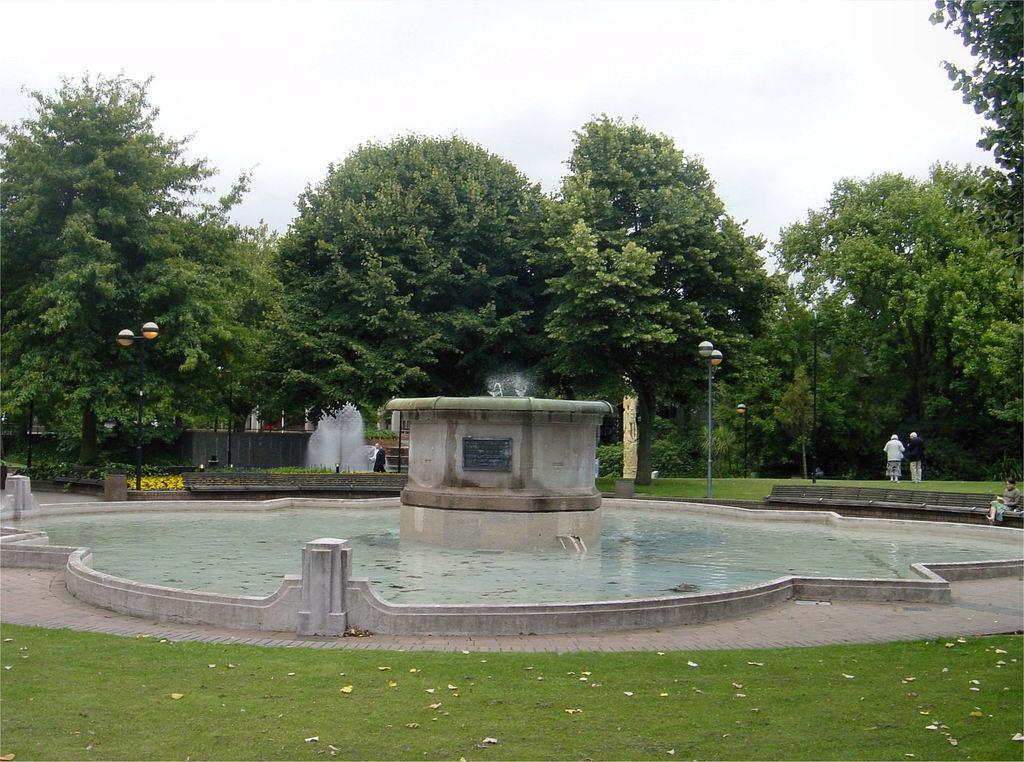In one or two sentences, can you explain what this image depicts? In the background we can see sky, trees, plants, persons, lights with poles. This is a water fountain. At the bottom we can see grass. 